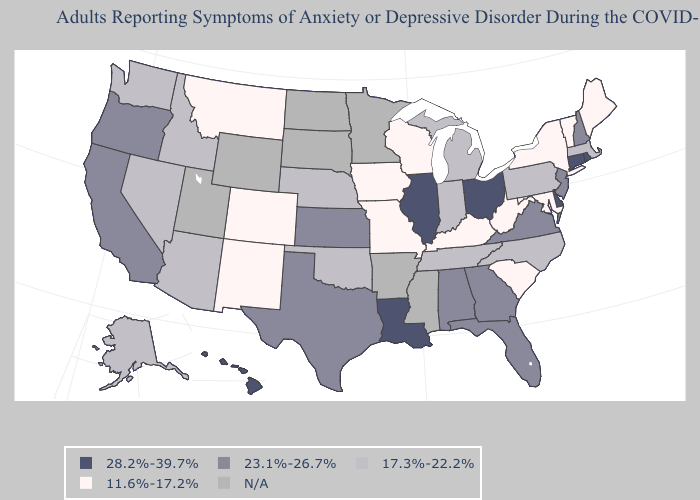Which states hav the highest value in the West?
Short answer required. Hawaii. Does Kentucky have the lowest value in the South?
Keep it brief. Yes. Which states have the lowest value in the Northeast?
Write a very short answer. Maine, New York, Vermont. Among the states that border Delaware , which have the highest value?
Be succinct. New Jersey. What is the value of Montana?
Be succinct. 11.6%-17.2%. Is the legend a continuous bar?
Quick response, please. No. What is the lowest value in the Northeast?
Give a very brief answer. 11.6%-17.2%. Among the states that border Texas , which have the highest value?
Be succinct. Louisiana. Name the states that have a value in the range 17.3%-22.2%?
Keep it brief. Alaska, Arizona, Idaho, Indiana, Massachusetts, Michigan, Nebraska, Nevada, North Carolina, Oklahoma, Pennsylvania, Tennessee, Washington. Name the states that have a value in the range 23.1%-26.7%?
Keep it brief. Alabama, California, Florida, Georgia, Kansas, New Hampshire, New Jersey, Oregon, Texas, Virginia. What is the value of South Carolina?
Be succinct. 11.6%-17.2%. Does the first symbol in the legend represent the smallest category?
Short answer required. No. Among the states that border Ohio , which have the lowest value?
Concise answer only. Kentucky, West Virginia. 